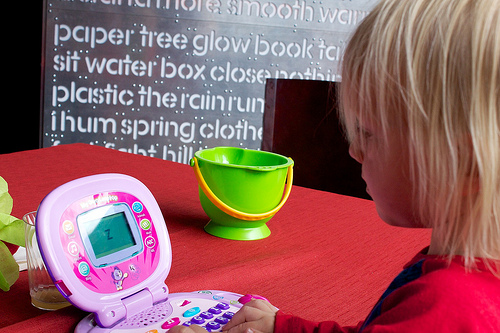<image>
Is the pail next to the girl? Yes. The pail is positioned adjacent to the girl, located nearby in the same general area. Where is the computer in relation to the table? Is it under the table? No. The computer is not positioned under the table. The vertical relationship between these objects is different. 